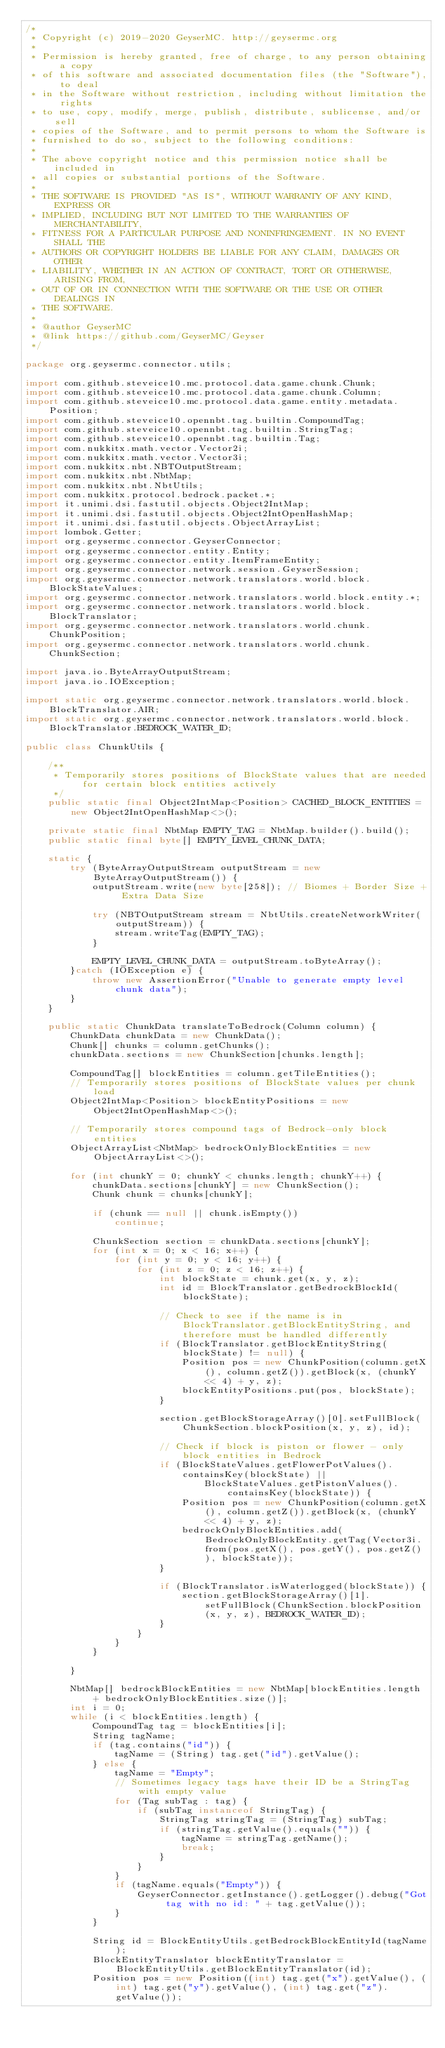Convert code to text. <code><loc_0><loc_0><loc_500><loc_500><_Java_>/*
 * Copyright (c) 2019-2020 GeyserMC. http://geysermc.org
 *
 * Permission is hereby granted, free of charge, to any person obtaining a copy
 * of this software and associated documentation files (the "Software"), to deal
 * in the Software without restriction, including without limitation the rights
 * to use, copy, modify, merge, publish, distribute, sublicense, and/or sell
 * copies of the Software, and to permit persons to whom the Software is
 * furnished to do so, subject to the following conditions:
 *
 * The above copyright notice and this permission notice shall be included in
 * all copies or substantial portions of the Software.
 *
 * THE SOFTWARE IS PROVIDED "AS IS", WITHOUT WARRANTY OF ANY KIND, EXPRESS OR
 * IMPLIED, INCLUDING BUT NOT LIMITED TO THE WARRANTIES OF MERCHANTABILITY,
 * FITNESS FOR A PARTICULAR PURPOSE AND NONINFRINGEMENT. IN NO EVENT SHALL THE
 * AUTHORS OR COPYRIGHT HOLDERS BE LIABLE FOR ANY CLAIM, DAMAGES OR OTHER
 * LIABILITY, WHETHER IN AN ACTION OF CONTRACT, TORT OR OTHERWISE, ARISING FROM,
 * OUT OF OR IN CONNECTION WITH THE SOFTWARE OR THE USE OR OTHER DEALINGS IN
 * THE SOFTWARE.
 *
 * @author GeyserMC
 * @link https://github.com/GeyserMC/Geyser
 */

package org.geysermc.connector.utils;

import com.github.steveice10.mc.protocol.data.game.chunk.Chunk;
import com.github.steveice10.mc.protocol.data.game.chunk.Column;
import com.github.steveice10.mc.protocol.data.game.entity.metadata.Position;
import com.github.steveice10.opennbt.tag.builtin.CompoundTag;
import com.github.steveice10.opennbt.tag.builtin.StringTag;
import com.github.steveice10.opennbt.tag.builtin.Tag;
import com.nukkitx.math.vector.Vector2i;
import com.nukkitx.math.vector.Vector3i;
import com.nukkitx.nbt.NBTOutputStream;
import com.nukkitx.nbt.NbtMap;
import com.nukkitx.nbt.NbtUtils;
import com.nukkitx.protocol.bedrock.packet.*;
import it.unimi.dsi.fastutil.objects.Object2IntMap;
import it.unimi.dsi.fastutil.objects.Object2IntOpenHashMap;
import it.unimi.dsi.fastutil.objects.ObjectArrayList;
import lombok.Getter;
import org.geysermc.connector.GeyserConnector;
import org.geysermc.connector.entity.Entity;
import org.geysermc.connector.entity.ItemFrameEntity;
import org.geysermc.connector.network.session.GeyserSession;
import org.geysermc.connector.network.translators.world.block.BlockStateValues;
import org.geysermc.connector.network.translators.world.block.entity.*;
import org.geysermc.connector.network.translators.world.block.BlockTranslator;
import org.geysermc.connector.network.translators.world.chunk.ChunkPosition;
import org.geysermc.connector.network.translators.world.chunk.ChunkSection;

import java.io.ByteArrayOutputStream;
import java.io.IOException;

import static org.geysermc.connector.network.translators.world.block.BlockTranslator.AIR;
import static org.geysermc.connector.network.translators.world.block.BlockTranslator.BEDROCK_WATER_ID;

public class ChunkUtils {

    /**
     * Temporarily stores positions of BlockState values that are needed for certain block entities actively
     */
    public static final Object2IntMap<Position> CACHED_BLOCK_ENTITIES = new Object2IntOpenHashMap<>();

    private static final NbtMap EMPTY_TAG = NbtMap.builder().build();
    public static final byte[] EMPTY_LEVEL_CHUNK_DATA;

    static {
        try (ByteArrayOutputStream outputStream = new ByteArrayOutputStream()) {
            outputStream.write(new byte[258]); // Biomes + Border Size + Extra Data Size

            try (NBTOutputStream stream = NbtUtils.createNetworkWriter(outputStream)) {
                stream.writeTag(EMPTY_TAG);
            }

            EMPTY_LEVEL_CHUNK_DATA = outputStream.toByteArray();
        }catch (IOException e) {
            throw new AssertionError("Unable to generate empty level chunk data");
        }
    }

    public static ChunkData translateToBedrock(Column column) {
        ChunkData chunkData = new ChunkData();
        Chunk[] chunks = column.getChunks();
        chunkData.sections = new ChunkSection[chunks.length];

        CompoundTag[] blockEntities = column.getTileEntities();
        // Temporarily stores positions of BlockState values per chunk load
        Object2IntMap<Position> blockEntityPositions = new Object2IntOpenHashMap<>();

        // Temporarily stores compound tags of Bedrock-only block entities
        ObjectArrayList<NbtMap> bedrockOnlyBlockEntities = new ObjectArrayList<>();

        for (int chunkY = 0; chunkY < chunks.length; chunkY++) {
            chunkData.sections[chunkY] = new ChunkSection();
            Chunk chunk = chunks[chunkY];

            if (chunk == null || chunk.isEmpty())
                continue;

            ChunkSection section = chunkData.sections[chunkY];
            for (int x = 0; x < 16; x++) {
                for (int y = 0; y < 16; y++) {
                    for (int z = 0; z < 16; z++) {
                        int blockState = chunk.get(x, y, z);
                        int id = BlockTranslator.getBedrockBlockId(blockState);

                        // Check to see if the name is in BlockTranslator.getBlockEntityString, and therefore must be handled differently
                        if (BlockTranslator.getBlockEntityString(blockState) != null) {
                            Position pos = new ChunkPosition(column.getX(), column.getZ()).getBlock(x, (chunkY << 4) + y, z);
                            blockEntityPositions.put(pos, blockState);
                        }

                        section.getBlockStorageArray()[0].setFullBlock(ChunkSection.blockPosition(x, y, z), id);

                        // Check if block is piston or flower - only block entities in Bedrock
                        if (BlockStateValues.getFlowerPotValues().containsKey(blockState) ||
                                BlockStateValues.getPistonValues().containsKey(blockState)) {
                            Position pos = new ChunkPosition(column.getX(), column.getZ()).getBlock(x, (chunkY << 4) + y, z);
                            bedrockOnlyBlockEntities.add(BedrockOnlyBlockEntity.getTag(Vector3i.from(pos.getX(), pos.getY(), pos.getZ()), blockState));
                        }

                        if (BlockTranslator.isWaterlogged(blockState)) {
                            section.getBlockStorageArray()[1].setFullBlock(ChunkSection.blockPosition(x, y, z), BEDROCK_WATER_ID);
                        }
                    }
                }
            }

        }

        NbtMap[] bedrockBlockEntities = new NbtMap[blockEntities.length + bedrockOnlyBlockEntities.size()];
        int i = 0;
        while (i < blockEntities.length) {
            CompoundTag tag = blockEntities[i];
            String tagName;
            if (tag.contains("id")) {
                tagName = (String) tag.get("id").getValue();
            } else {
                tagName = "Empty";
                // Sometimes legacy tags have their ID be a StringTag with empty value
                for (Tag subTag : tag) {
                    if (subTag instanceof StringTag) {
                        StringTag stringTag = (StringTag) subTag;
                        if (stringTag.getValue().equals("")) {
                            tagName = stringTag.getName();
                            break;
                        }
                    }
                }
                if (tagName.equals("Empty")) {
                    GeyserConnector.getInstance().getLogger().debug("Got tag with no id: " + tag.getValue());
                }
            }

            String id = BlockEntityUtils.getBedrockBlockEntityId(tagName);
            BlockEntityTranslator blockEntityTranslator = BlockEntityUtils.getBlockEntityTranslator(id);
            Position pos = new Position((int) tag.get("x").getValue(), (int) tag.get("y").getValue(), (int) tag.get("z").getValue());</code> 